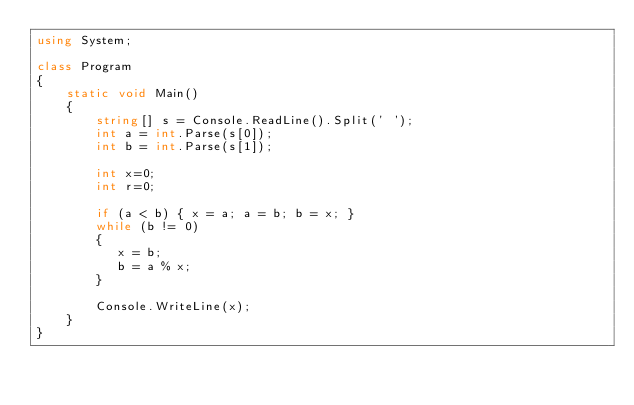Convert code to text. <code><loc_0><loc_0><loc_500><loc_500><_C#_>using System;
 
class Program
{
    static void Main()
    {
        string[] s = Console.ReadLine().Split(' ');
        int a = int.Parse(s[0]);
        int b = int.Parse(s[1]);
        
        int x=0;
        int r=0;
        
        if (a < b) { x = a; a = b; b = x; }
        while (b != 0)
        {
           x = b;
           b = a % x;
        }
        
        Console.WriteLine(x);
    }
}
</code> 